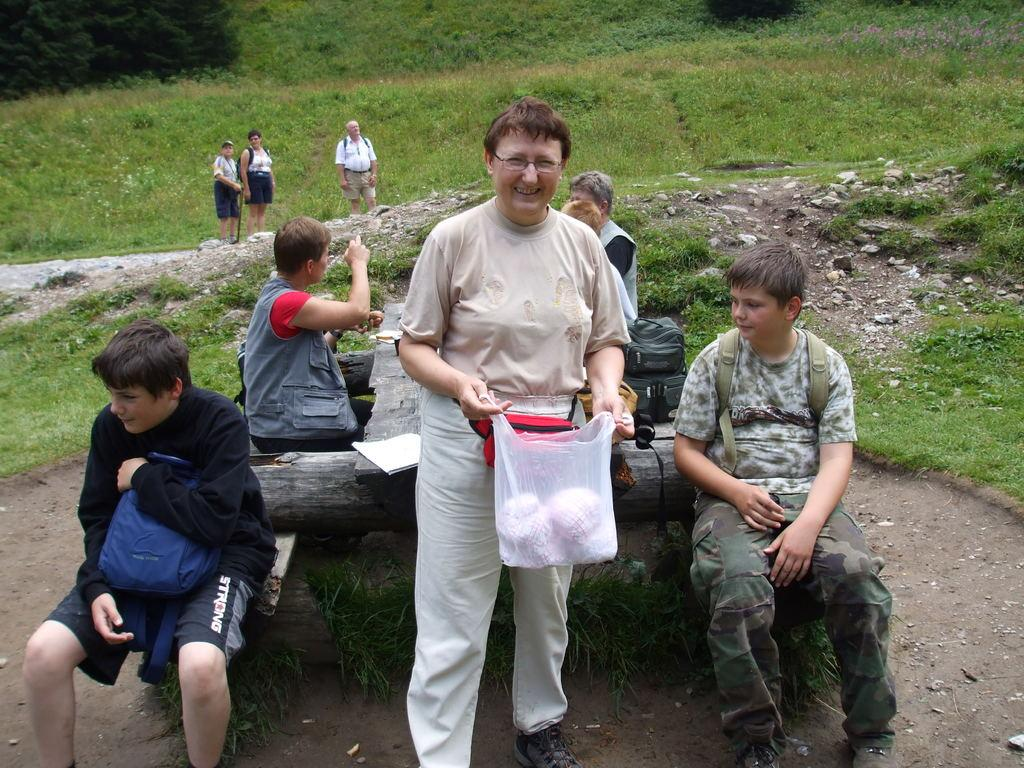How many people are sitting in the image? There are four people sitting on a log in the image. How many people are standing in the image? There are four people standing in the image. What can be seen in the background of the image? There is a green field in the background of the image. What type of power source is being used by the people in the image? There is no indication of any power source being used by the people in the image. 